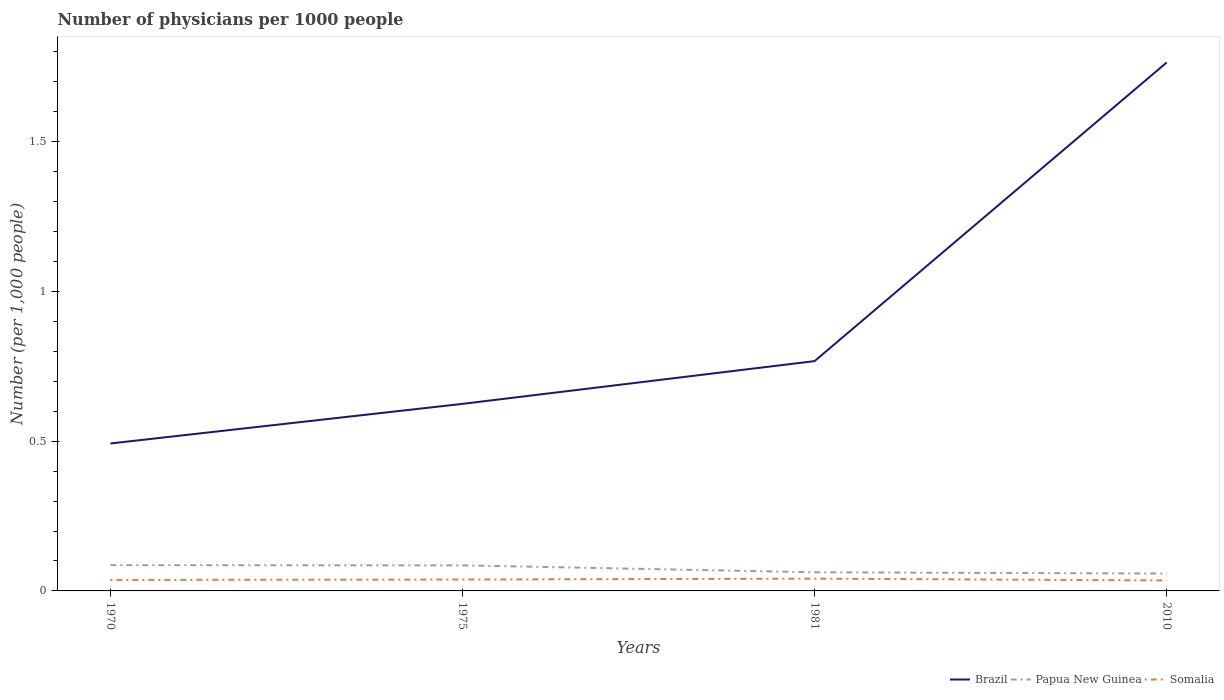How many different coloured lines are there?
Keep it short and to the point. 3. Across all years, what is the maximum number of physicians in Somalia?
Offer a terse response. 0.04. In which year was the number of physicians in Brazil maximum?
Provide a short and direct response. 1970. What is the total number of physicians in Brazil in the graph?
Make the answer very short. -0.14. What is the difference between the highest and the second highest number of physicians in Somalia?
Offer a very short reply. 0.01. What is the difference between the highest and the lowest number of physicians in Somalia?
Your response must be concise. 2. Is the number of physicians in Papua New Guinea strictly greater than the number of physicians in Somalia over the years?
Your answer should be very brief. No. Are the values on the major ticks of Y-axis written in scientific E-notation?
Give a very brief answer. No. Does the graph contain any zero values?
Provide a succinct answer. No. Does the graph contain grids?
Give a very brief answer. No. What is the title of the graph?
Give a very brief answer. Number of physicians per 1000 people. What is the label or title of the Y-axis?
Keep it short and to the point. Number (per 1,0 people). What is the Number (per 1,000 people) of Brazil in 1970?
Offer a very short reply. 0.49. What is the Number (per 1,000 people) in Papua New Guinea in 1970?
Make the answer very short. 0.09. What is the Number (per 1,000 people) of Somalia in 1970?
Provide a short and direct response. 0.04. What is the Number (per 1,000 people) of Brazil in 1975?
Your response must be concise. 0.62. What is the Number (per 1,000 people) in Papua New Guinea in 1975?
Provide a short and direct response. 0.09. What is the Number (per 1,000 people) in Somalia in 1975?
Make the answer very short. 0.04. What is the Number (per 1,000 people) in Brazil in 1981?
Offer a very short reply. 0.77. What is the Number (per 1,000 people) in Papua New Guinea in 1981?
Your answer should be very brief. 0.06. What is the Number (per 1,000 people) of Somalia in 1981?
Your response must be concise. 0.04. What is the Number (per 1,000 people) in Brazil in 2010?
Provide a short and direct response. 1.76. What is the Number (per 1,000 people) in Papua New Guinea in 2010?
Your answer should be very brief. 0.06. What is the Number (per 1,000 people) in Somalia in 2010?
Offer a very short reply. 0.04. Across all years, what is the maximum Number (per 1,000 people) in Brazil?
Keep it short and to the point. 1.76. Across all years, what is the maximum Number (per 1,000 people) of Papua New Guinea?
Give a very brief answer. 0.09. Across all years, what is the maximum Number (per 1,000 people) of Somalia?
Your response must be concise. 0.04. Across all years, what is the minimum Number (per 1,000 people) in Brazil?
Ensure brevity in your answer.  0.49. Across all years, what is the minimum Number (per 1,000 people) of Papua New Guinea?
Provide a short and direct response. 0.06. Across all years, what is the minimum Number (per 1,000 people) in Somalia?
Provide a succinct answer. 0.04. What is the total Number (per 1,000 people) of Brazil in the graph?
Offer a very short reply. 3.65. What is the total Number (per 1,000 people) in Papua New Guinea in the graph?
Provide a short and direct response. 0.29. What is the total Number (per 1,000 people) in Somalia in the graph?
Provide a succinct answer. 0.15. What is the difference between the Number (per 1,000 people) of Brazil in 1970 and that in 1975?
Ensure brevity in your answer.  -0.13. What is the difference between the Number (per 1,000 people) in Somalia in 1970 and that in 1975?
Your answer should be compact. -0. What is the difference between the Number (per 1,000 people) in Brazil in 1970 and that in 1981?
Your answer should be compact. -0.27. What is the difference between the Number (per 1,000 people) in Papua New Guinea in 1970 and that in 1981?
Your answer should be compact. 0.02. What is the difference between the Number (per 1,000 people) of Somalia in 1970 and that in 1981?
Offer a terse response. -0. What is the difference between the Number (per 1,000 people) of Brazil in 1970 and that in 2010?
Give a very brief answer. -1.27. What is the difference between the Number (per 1,000 people) of Papua New Guinea in 1970 and that in 2010?
Your answer should be compact. 0.03. What is the difference between the Number (per 1,000 people) in Somalia in 1970 and that in 2010?
Provide a short and direct response. 0. What is the difference between the Number (per 1,000 people) in Brazil in 1975 and that in 1981?
Offer a very short reply. -0.14. What is the difference between the Number (per 1,000 people) of Papua New Guinea in 1975 and that in 1981?
Keep it short and to the point. 0.02. What is the difference between the Number (per 1,000 people) of Somalia in 1975 and that in 1981?
Keep it short and to the point. -0. What is the difference between the Number (per 1,000 people) of Brazil in 1975 and that in 2010?
Your answer should be compact. -1.14. What is the difference between the Number (per 1,000 people) of Papua New Guinea in 1975 and that in 2010?
Provide a succinct answer. 0.03. What is the difference between the Number (per 1,000 people) of Somalia in 1975 and that in 2010?
Make the answer very short. 0. What is the difference between the Number (per 1,000 people) of Brazil in 1981 and that in 2010?
Offer a very short reply. -1. What is the difference between the Number (per 1,000 people) in Papua New Guinea in 1981 and that in 2010?
Give a very brief answer. 0. What is the difference between the Number (per 1,000 people) of Somalia in 1981 and that in 2010?
Offer a very short reply. 0.01. What is the difference between the Number (per 1,000 people) of Brazil in 1970 and the Number (per 1,000 people) of Papua New Guinea in 1975?
Offer a very short reply. 0.41. What is the difference between the Number (per 1,000 people) of Brazil in 1970 and the Number (per 1,000 people) of Somalia in 1975?
Your response must be concise. 0.45. What is the difference between the Number (per 1,000 people) in Papua New Guinea in 1970 and the Number (per 1,000 people) in Somalia in 1975?
Give a very brief answer. 0.05. What is the difference between the Number (per 1,000 people) of Brazil in 1970 and the Number (per 1,000 people) of Papua New Guinea in 1981?
Provide a succinct answer. 0.43. What is the difference between the Number (per 1,000 people) in Brazil in 1970 and the Number (per 1,000 people) in Somalia in 1981?
Make the answer very short. 0.45. What is the difference between the Number (per 1,000 people) in Papua New Guinea in 1970 and the Number (per 1,000 people) in Somalia in 1981?
Ensure brevity in your answer.  0.04. What is the difference between the Number (per 1,000 people) of Brazil in 1970 and the Number (per 1,000 people) of Papua New Guinea in 2010?
Provide a succinct answer. 0.43. What is the difference between the Number (per 1,000 people) in Brazil in 1970 and the Number (per 1,000 people) in Somalia in 2010?
Your answer should be very brief. 0.46. What is the difference between the Number (per 1,000 people) in Papua New Guinea in 1970 and the Number (per 1,000 people) in Somalia in 2010?
Offer a very short reply. 0.05. What is the difference between the Number (per 1,000 people) in Brazil in 1975 and the Number (per 1,000 people) in Papua New Guinea in 1981?
Provide a short and direct response. 0.56. What is the difference between the Number (per 1,000 people) in Brazil in 1975 and the Number (per 1,000 people) in Somalia in 1981?
Your response must be concise. 0.58. What is the difference between the Number (per 1,000 people) of Papua New Guinea in 1975 and the Number (per 1,000 people) of Somalia in 1981?
Keep it short and to the point. 0.04. What is the difference between the Number (per 1,000 people) of Brazil in 1975 and the Number (per 1,000 people) of Papua New Guinea in 2010?
Give a very brief answer. 0.57. What is the difference between the Number (per 1,000 people) of Brazil in 1975 and the Number (per 1,000 people) of Somalia in 2010?
Ensure brevity in your answer.  0.59. What is the difference between the Number (per 1,000 people) of Papua New Guinea in 1975 and the Number (per 1,000 people) of Somalia in 2010?
Provide a short and direct response. 0.05. What is the difference between the Number (per 1,000 people) of Brazil in 1981 and the Number (per 1,000 people) of Papua New Guinea in 2010?
Ensure brevity in your answer.  0.71. What is the difference between the Number (per 1,000 people) in Brazil in 1981 and the Number (per 1,000 people) in Somalia in 2010?
Your response must be concise. 0.73. What is the difference between the Number (per 1,000 people) in Papua New Guinea in 1981 and the Number (per 1,000 people) in Somalia in 2010?
Offer a very short reply. 0.03. What is the average Number (per 1,000 people) of Brazil per year?
Give a very brief answer. 0.91. What is the average Number (per 1,000 people) of Papua New Guinea per year?
Make the answer very short. 0.07. What is the average Number (per 1,000 people) of Somalia per year?
Keep it short and to the point. 0.04. In the year 1970, what is the difference between the Number (per 1,000 people) of Brazil and Number (per 1,000 people) of Papua New Guinea?
Your answer should be compact. 0.41. In the year 1970, what is the difference between the Number (per 1,000 people) in Brazil and Number (per 1,000 people) in Somalia?
Provide a short and direct response. 0.46. In the year 1970, what is the difference between the Number (per 1,000 people) of Papua New Guinea and Number (per 1,000 people) of Somalia?
Provide a short and direct response. 0.05. In the year 1975, what is the difference between the Number (per 1,000 people) of Brazil and Number (per 1,000 people) of Papua New Guinea?
Offer a terse response. 0.54. In the year 1975, what is the difference between the Number (per 1,000 people) in Brazil and Number (per 1,000 people) in Somalia?
Offer a very short reply. 0.59. In the year 1975, what is the difference between the Number (per 1,000 people) of Papua New Guinea and Number (per 1,000 people) of Somalia?
Keep it short and to the point. 0.05. In the year 1981, what is the difference between the Number (per 1,000 people) of Brazil and Number (per 1,000 people) of Papua New Guinea?
Make the answer very short. 0.7. In the year 1981, what is the difference between the Number (per 1,000 people) of Brazil and Number (per 1,000 people) of Somalia?
Offer a terse response. 0.73. In the year 1981, what is the difference between the Number (per 1,000 people) of Papua New Guinea and Number (per 1,000 people) of Somalia?
Offer a terse response. 0.02. In the year 2010, what is the difference between the Number (per 1,000 people) of Brazil and Number (per 1,000 people) of Papua New Guinea?
Provide a succinct answer. 1.71. In the year 2010, what is the difference between the Number (per 1,000 people) in Brazil and Number (per 1,000 people) in Somalia?
Offer a terse response. 1.73. In the year 2010, what is the difference between the Number (per 1,000 people) of Papua New Guinea and Number (per 1,000 people) of Somalia?
Offer a terse response. 0.02. What is the ratio of the Number (per 1,000 people) of Brazil in 1970 to that in 1975?
Provide a succinct answer. 0.79. What is the ratio of the Number (per 1,000 people) in Papua New Guinea in 1970 to that in 1975?
Provide a succinct answer. 1.01. What is the ratio of the Number (per 1,000 people) of Somalia in 1970 to that in 1975?
Give a very brief answer. 0.97. What is the ratio of the Number (per 1,000 people) of Brazil in 1970 to that in 1981?
Make the answer very short. 0.64. What is the ratio of the Number (per 1,000 people) of Papua New Guinea in 1970 to that in 1981?
Your answer should be compact. 1.38. What is the ratio of the Number (per 1,000 people) of Somalia in 1970 to that in 1981?
Keep it short and to the point. 0.9. What is the ratio of the Number (per 1,000 people) in Brazil in 1970 to that in 2010?
Offer a very short reply. 0.28. What is the ratio of the Number (per 1,000 people) of Papua New Guinea in 1970 to that in 2010?
Offer a terse response. 1.48. What is the ratio of the Number (per 1,000 people) of Somalia in 1970 to that in 2010?
Provide a succinct answer. 1.05. What is the ratio of the Number (per 1,000 people) of Brazil in 1975 to that in 1981?
Provide a short and direct response. 0.81. What is the ratio of the Number (per 1,000 people) in Papua New Guinea in 1975 to that in 1981?
Offer a terse response. 1.37. What is the ratio of the Number (per 1,000 people) of Somalia in 1975 to that in 1981?
Provide a short and direct response. 0.93. What is the ratio of the Number (per 1,000 people) in Brazil in 1975 to that in 2010?
Keep it short and to the point. 0.35. What is the ratio of the Number (per 1,000 people) of Papua New Guinea in 1975 to that in 2010?
Provide a short and direct response. 1.47. What is the ratio of the Number (per 1,000 people) of Somalia in 1975 to that in 2010?
Provide a succinct answer. 1.09. What is the ratio of the Number (per 1,000 people) of Brazil in 1981 to that in 2010?
Make the answer very short. 0.43. What is the ratio of the Number (per 1,000 people) of Papua New Guinea in 1981 to that in 2010?
Offer a terse response. 1.07. What is the ratio of the Number (per 1,000 people) of Somalia in 1981 to that in 2010?
Your response must be concise. 1.17. What is the difference between the highest and the second highest Number (per 1,000 people) in Somalia?
Ensure brevity in your answer.  0. What is the difference between the highest and the lowest Number (per 1,000 people) in Brazil?
Your response must be concise. 1.27. What is the difference between the highest and the lowest Number (per 1,000 people) of Papua New Guinea?
Give a very brief answer. 0.03. What is the difference between the highest and the lowest Number (per 1,000 people) in Somalia?
Keep it short and to the point. 0.01. 